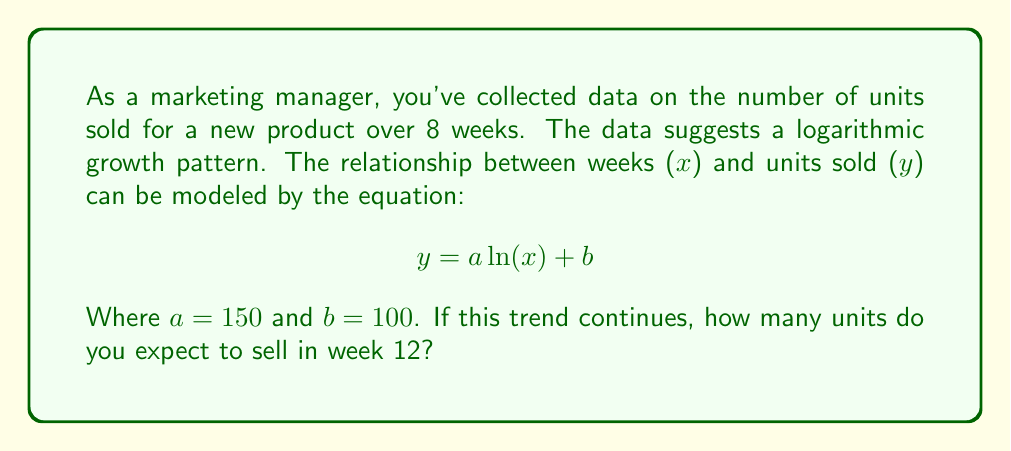What is the answer to this math problem? To solve this problem, we'll follow these steps:

1. Understand the given logarithmic regression model:
   $$ y = a \ln(x) + b $$
   Where $y$ is the number of units sold, $x$ is the number of weeks, $a = 150$, and $b = 100$.

2. Substitute the given values and the week number (x = 12) into the equation:
   $$ y = 150 \ln(12) + 100 $$

3. Calculate $\ln(12)$:
   $\ln(12) \approx 2.4849$

4. Multiply this by $a$ (150):
   $150 * 2.4849 \approx 372.735$

5. Add $b$ (100) to the result:
   $372.735 + 100 = 472.735$

6. Round to the nearest whole number, as we can't sell partial units:
   $472.735 \approx 473$

This logarithmic model helps predict consumer behavior by showing how sales growth slows over time while still increasing, which is common for new product launches.
Answer: 473 units 